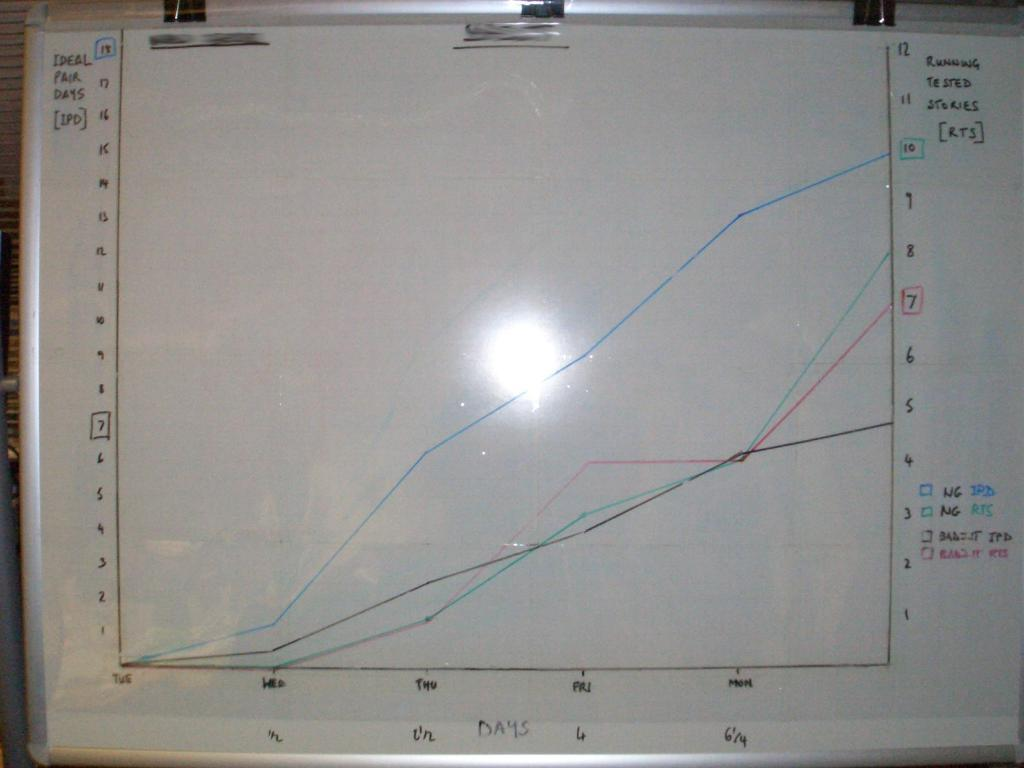<image>
Share a concise interpretation of the image provided. A line graph with Ideal Pair days (IPD) in the y axis and days in the x axis 